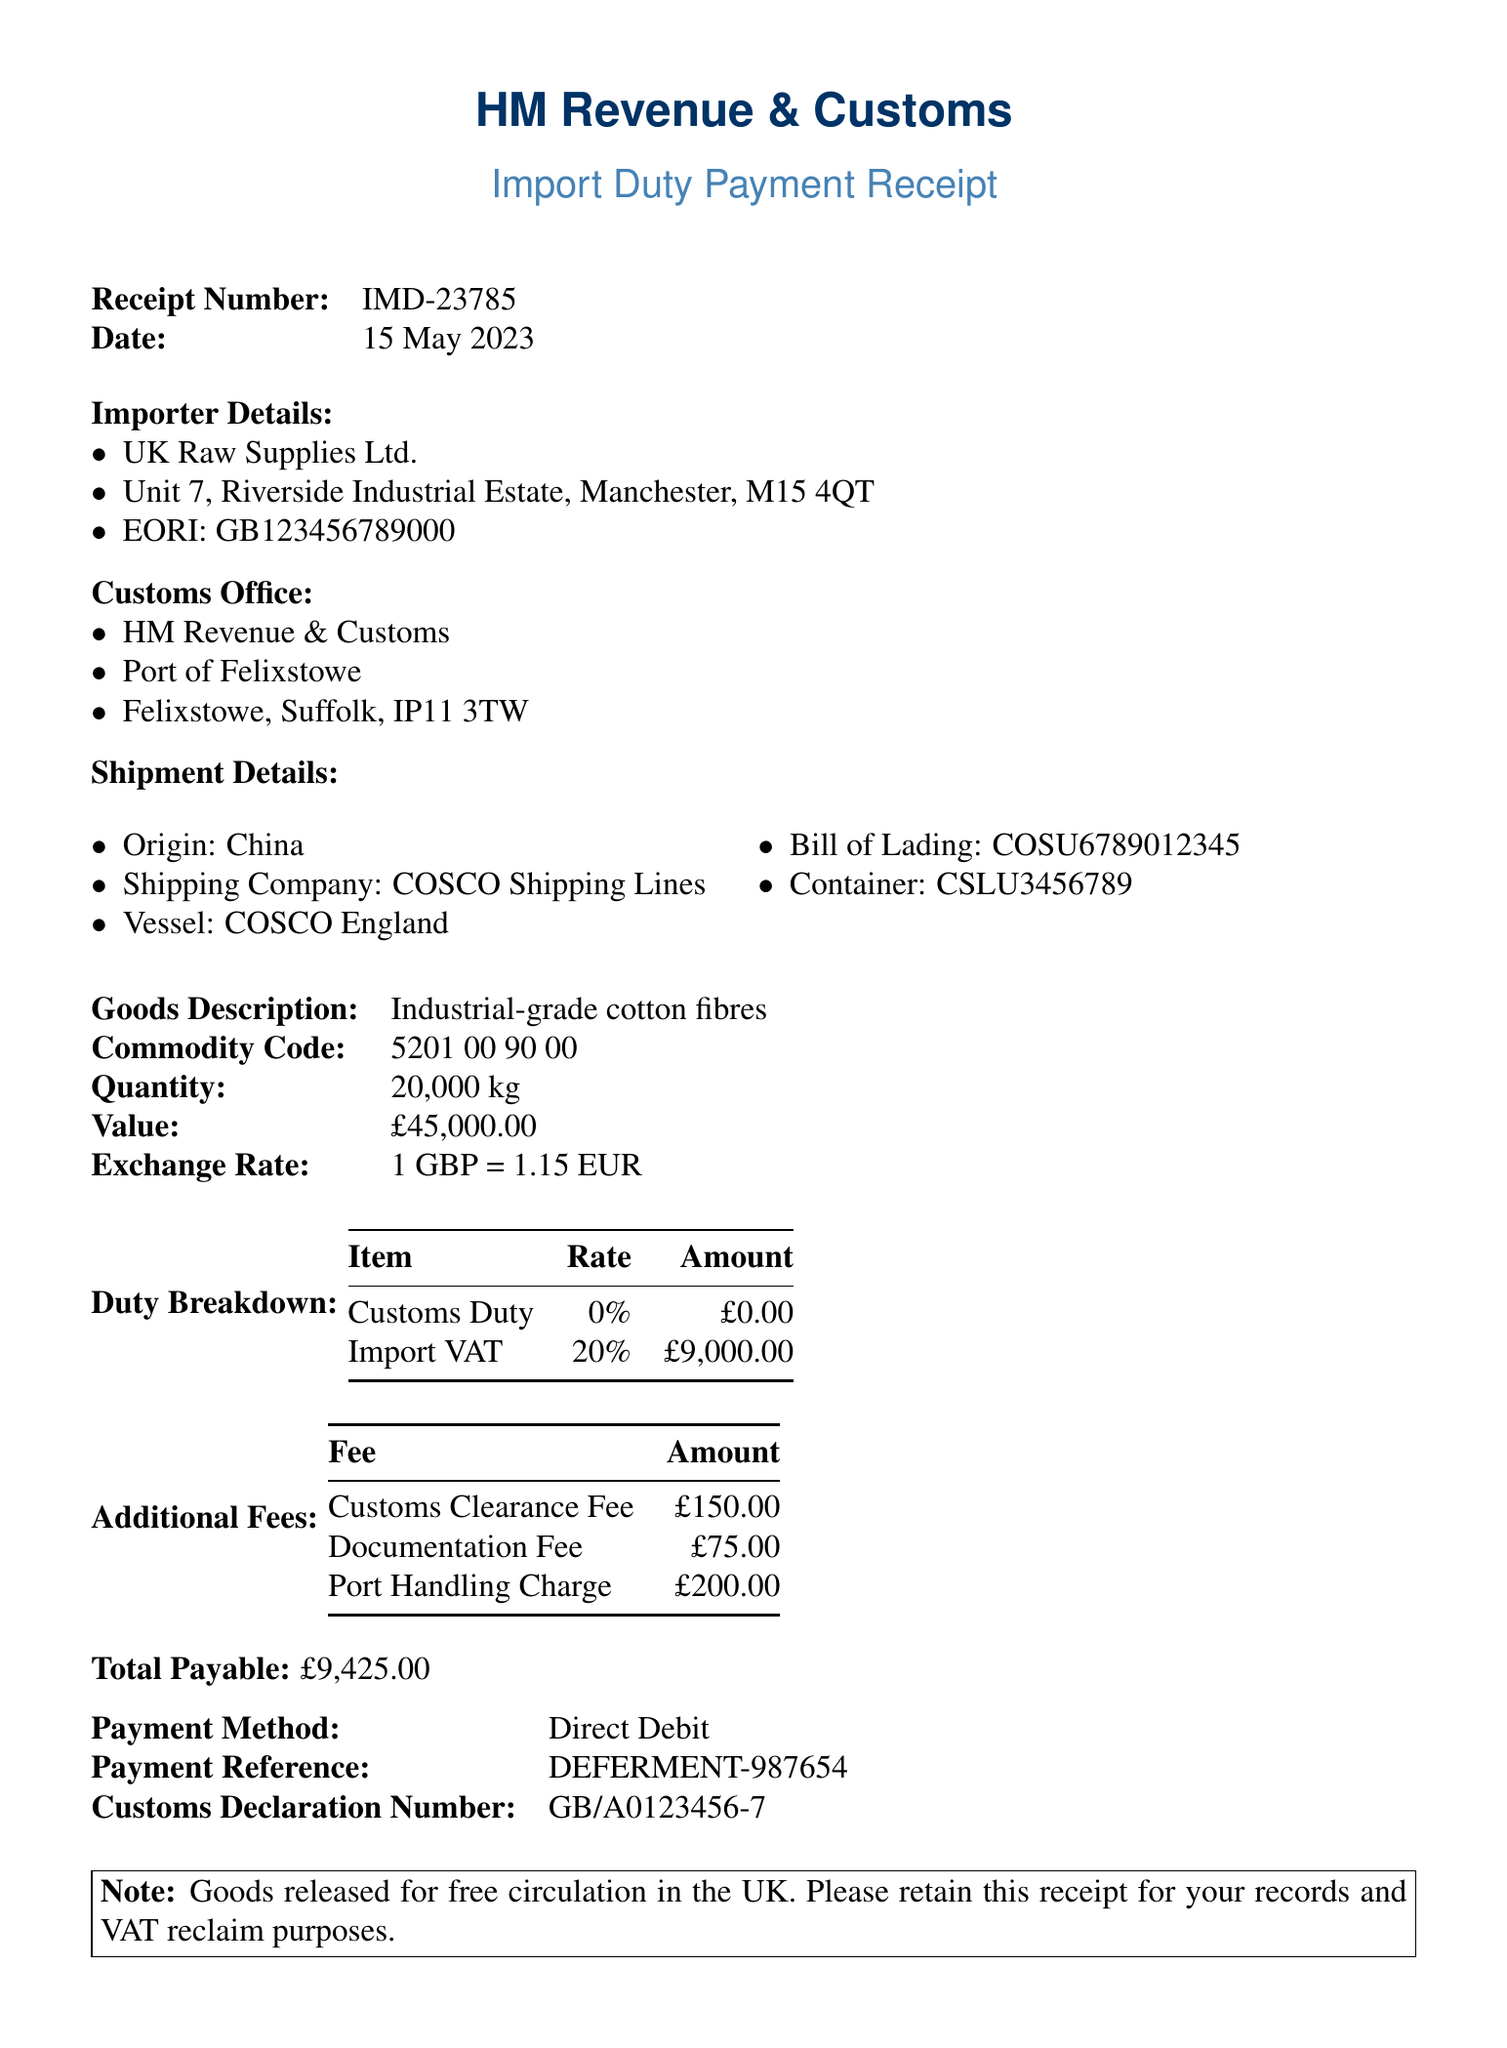What is the receipt number? The receipt number is explicitly stated in the document for identification purposes.
Answer: IMD-23785 What is the date of the transaction? The date is important for record-keeping and is clearly mentioned in the receipt.
Answer: 15 May 2023 What is the name of the importer? The importer's name is provided in the importer details section of the document.
Answer: UK Raw Supplies Ltd What is the total amount payable? The total payable amount is summarized at the end of the document.
Answer: £9,425.00 What is the import VAT rate? The import VAT rate is included in the duty breakdown section, indicating tax information.
Answer: 20% How much is the customs clearance fee? The customs clearance fee is listed under additional fees, specifying processing costs.
Answer: £150.00 What type of goods are being imported? The type of goods specifies the nature of the shipment and is included in the goods description.
Answer: Industrial-grade cotton fibres What is the origin country of the shipment? The country of origin is mentioned in the shipment details and is relevant for import regulations.
Answer: China What is the payment method used? The payment method is specified at the end of the receipt, indicating how the fee was settled.
Answer: Direct Debit 